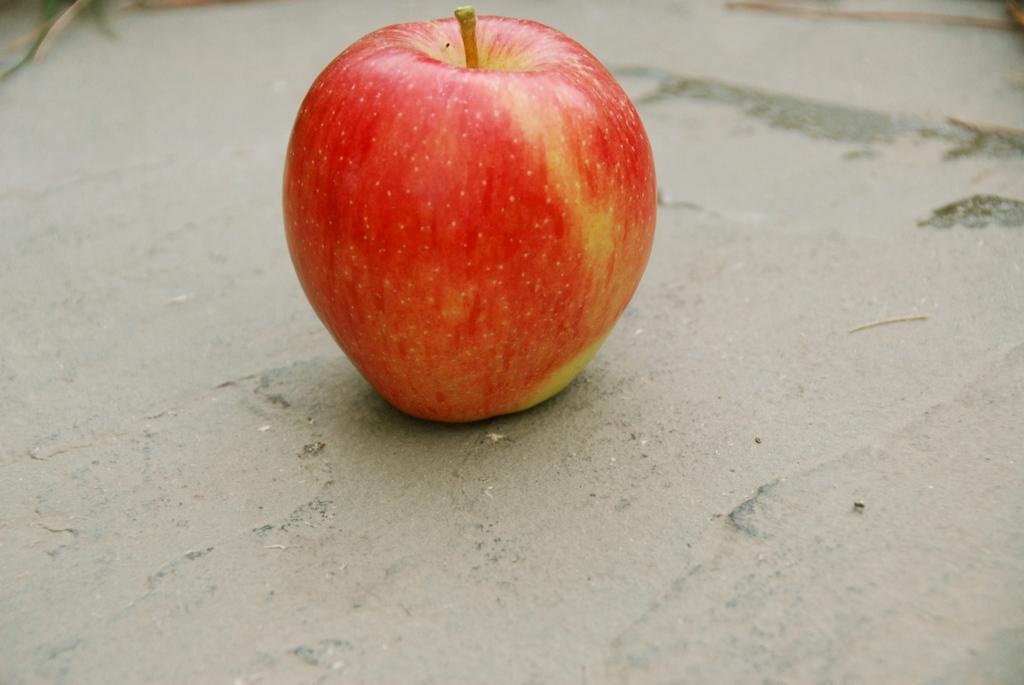Describe this image in one or two sentences. In this image, we can see an apple is placed on the surface. 